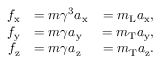Convert formula to latex. <formula><loc_0><loc_0><loc_500><loc_500>{ \begin{array} { r l r } { f _ { x } } & { = m \gamma ^ { 3 } a _ { x } } & { = m _ { L } a _ { x } , } \\ { f _ { y } } & { = m \gamma a _ { y } } & { = m _ { T } a _ { y } , } \\ { f _ { z } } & { = m \gamma a _ { z } } & { = m _ { T } a _ { z } . } \end{array} }</formula> 